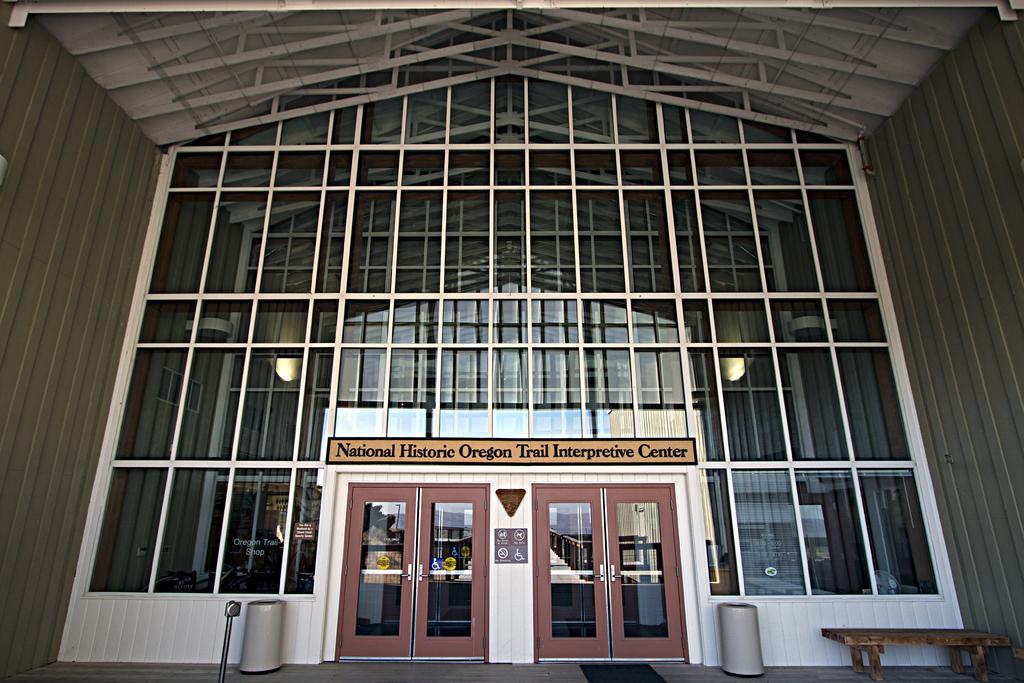In one or two sentences, can you explain what this image depicts? In this image I can see doors, a table and some other objects on the floor. I can also see framed glass wall, lights and other objects. 